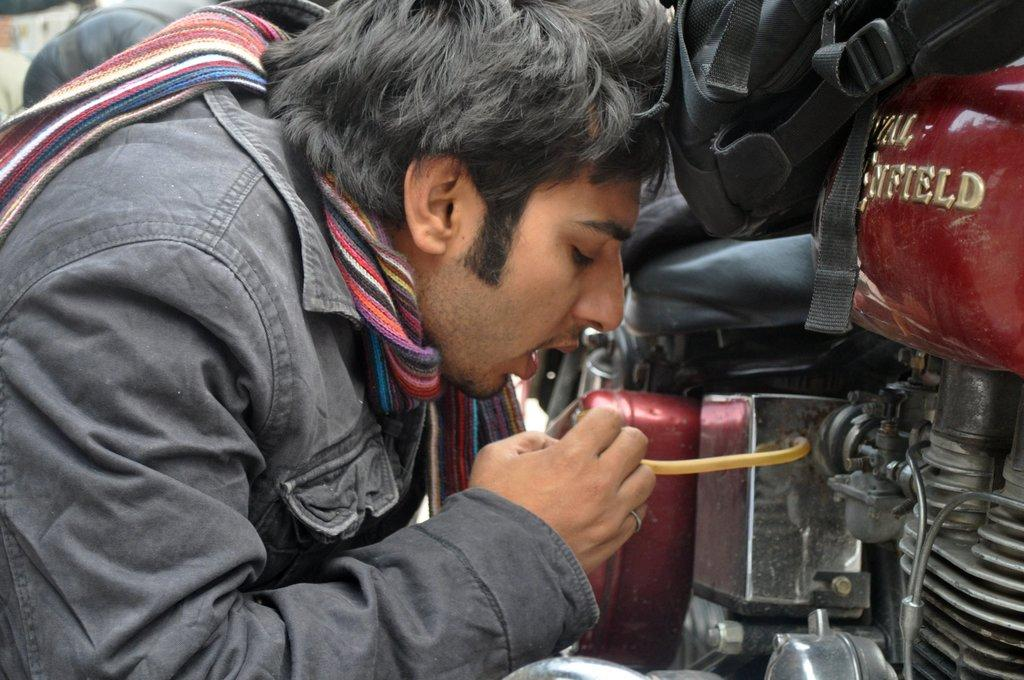What vehicle is located on the right side of the image? There is a motorcycle on the right side of the image. What is the man doing on the left side of the image? The man is standing on the left side of the image. What color is the jacket the man is wearing? The man is wearing a black color jacket. Can you tell me how many airports are visible in the image? There are no airports visible in the image; it features a motorcycle and a man. What type of show is the man participating in on the left side of the image? There is no show present in the image; the man is simply standing on the left side. 